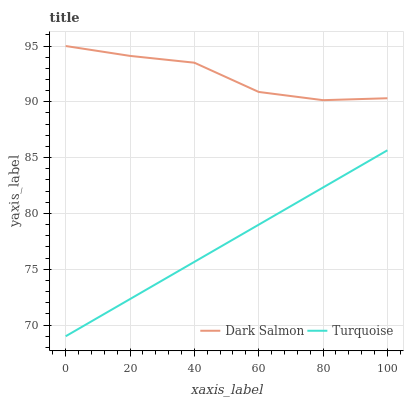Does Turquoise have the minimum area under the curve?
Answer yes or no. Yes. Does Dark Salmon have the maximum area under the curve?
Answer yes or no. Yes. Does Dark Salmon have the minimum area under the curve?
Answer yes or no. No. Is Turquoise the smoothest?
Answer yes or no. Yes. Is Dark Salmon the roughest?
Answer yes or no. Yes. Is Dark Salmon the smoothest?
Answer yes or no. No. Does Dark Salmon have the lowest value?
Answer yes or no. No. Is Turquoise less than Dark Salmon?
Answer yes or no. Yes. Is Dark Salmon greater than Turquoise?
Answer yes or no. Yes. Does Turquoise intersect Dark Salmon?
Answer yes or no. No. 